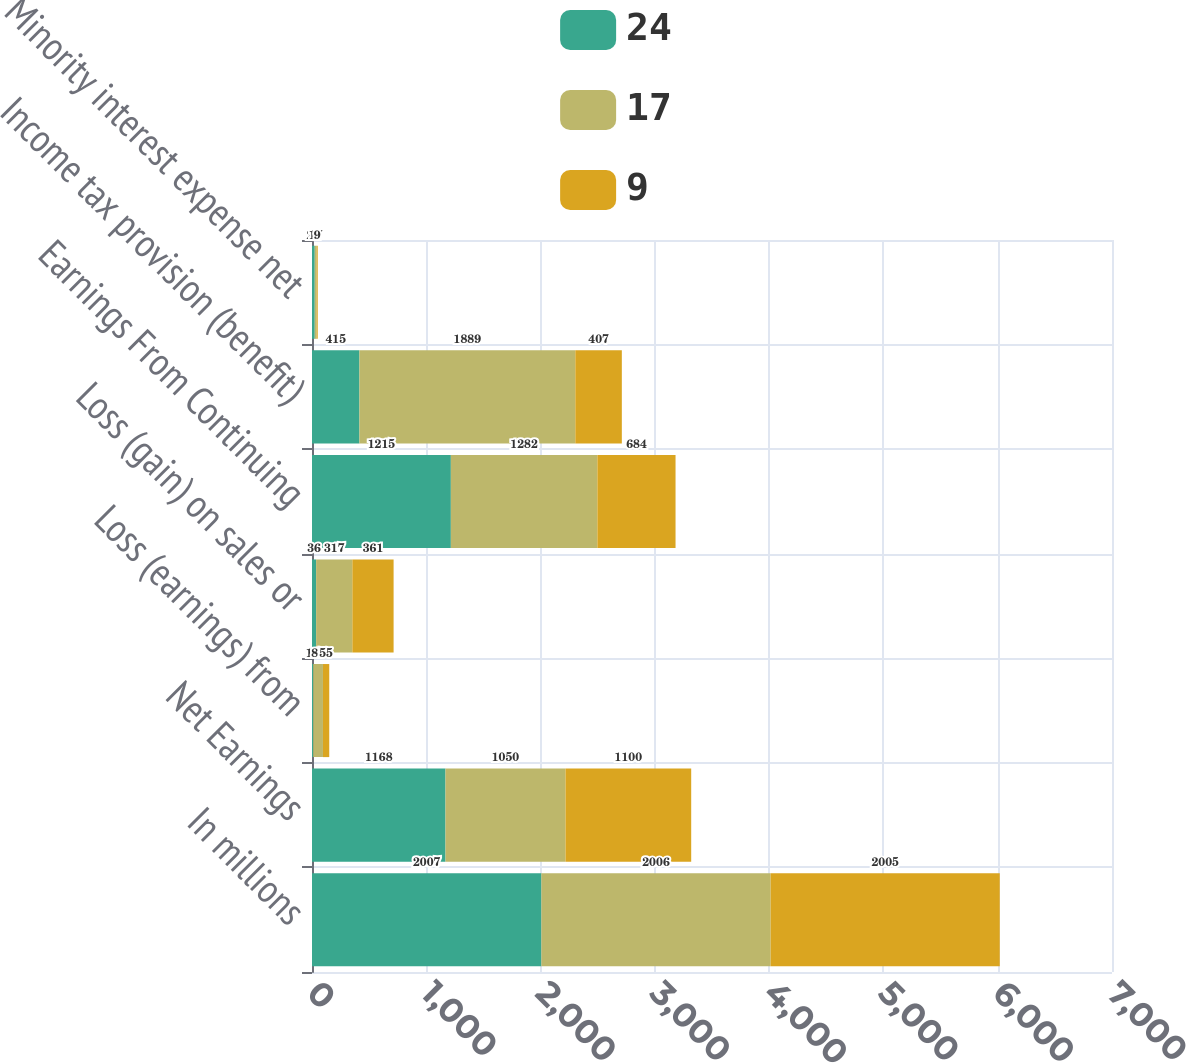<chart> <loc_0><loc_0><loc_500><loc_500><stacked_bar_chart><ecel><fcel>In millions<fcel>Net Earnings<fcel>Loss (earnings) from<fcel>Loss (gain) on sales or<fcel>Earnings From Continuing<fcel>Income tax provision (benefit)<fcel>Minority interest expense net<nl><fcel>24<fcel>2007<fcel>1168<fcel>11<fcel>36<fcel>1215<fcel>415<fcel>24<nl><fcel>17<fcel>2006<fcel>1050<fcel>85<fcel>317<fcel>1282<fcel>1889<fcel>17<nl><fcel>9<fcel>2005<fcel>1100<fcel>55<fcel>361<fcel>684<fcel>407<fcel>9<nl></chart> 